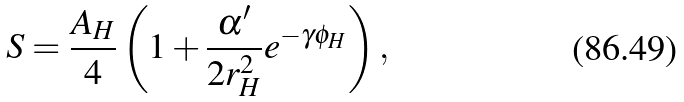Convert formula to latex. <formula><loc_0><loc_0><loc_500><loc_500>S = \frac { A _ { H } } { 4 } \left ( 1 + \frac { \alpha ^ { \prime } } { 2 r _ { H } ^ { 2 } } e ^ { - \gamma \phi _ { H } } \right ) ,</formula> 